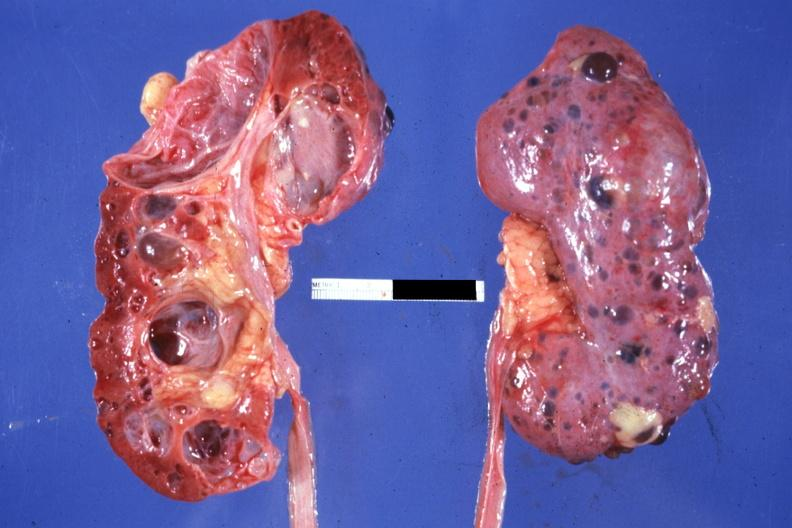what does this image show?
Answer the question using a single word or phrase. Nice photo one kidney opened the other from capsular surface many cysts 